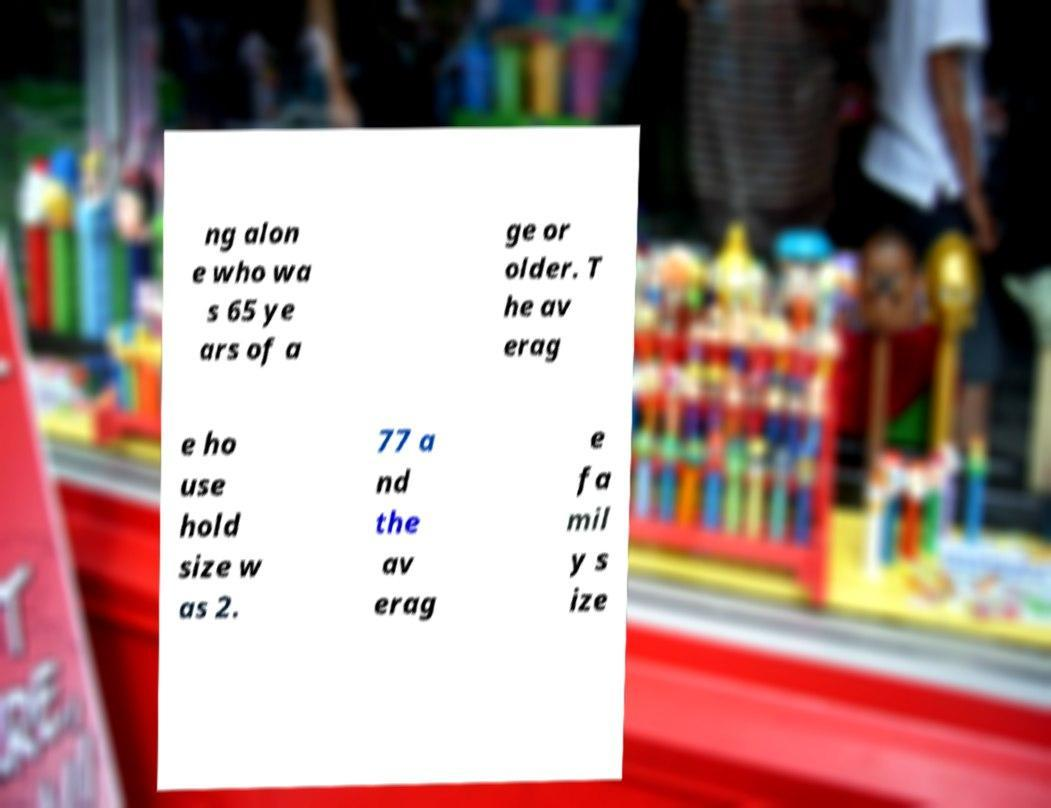For documentation purposes, I need the text within this image transcribed. Could you provide that? ng alon e who wa s 65 ye ars of a ge or older. T he av erag e ho use hold size w as 2. 77 a nd the av erag e fa mil y s ize 